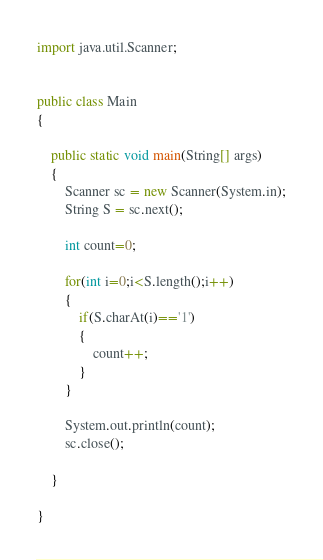<code> <loc_0><loc_0><loc_500><loc_500><_Java_>import java.util.Scanner;


public class Main
{

	public static void main(String[] args) 
	{
		Scanner sc = new Scanner(System.in);
		String S = sc.next();
		
		int count=0;
		
		for(int i=0;i<S.length();i++)
		{
			if(S.charAt(i)=='1')
			{
				count++;
			}
		}
		
		System.out.println(count);
		sc.close();

	}

}
</code> 